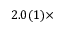<formula> <loc_0><loc_0><loc_500><loc_500>2 . 0 ( 1 ) \times</formula> 